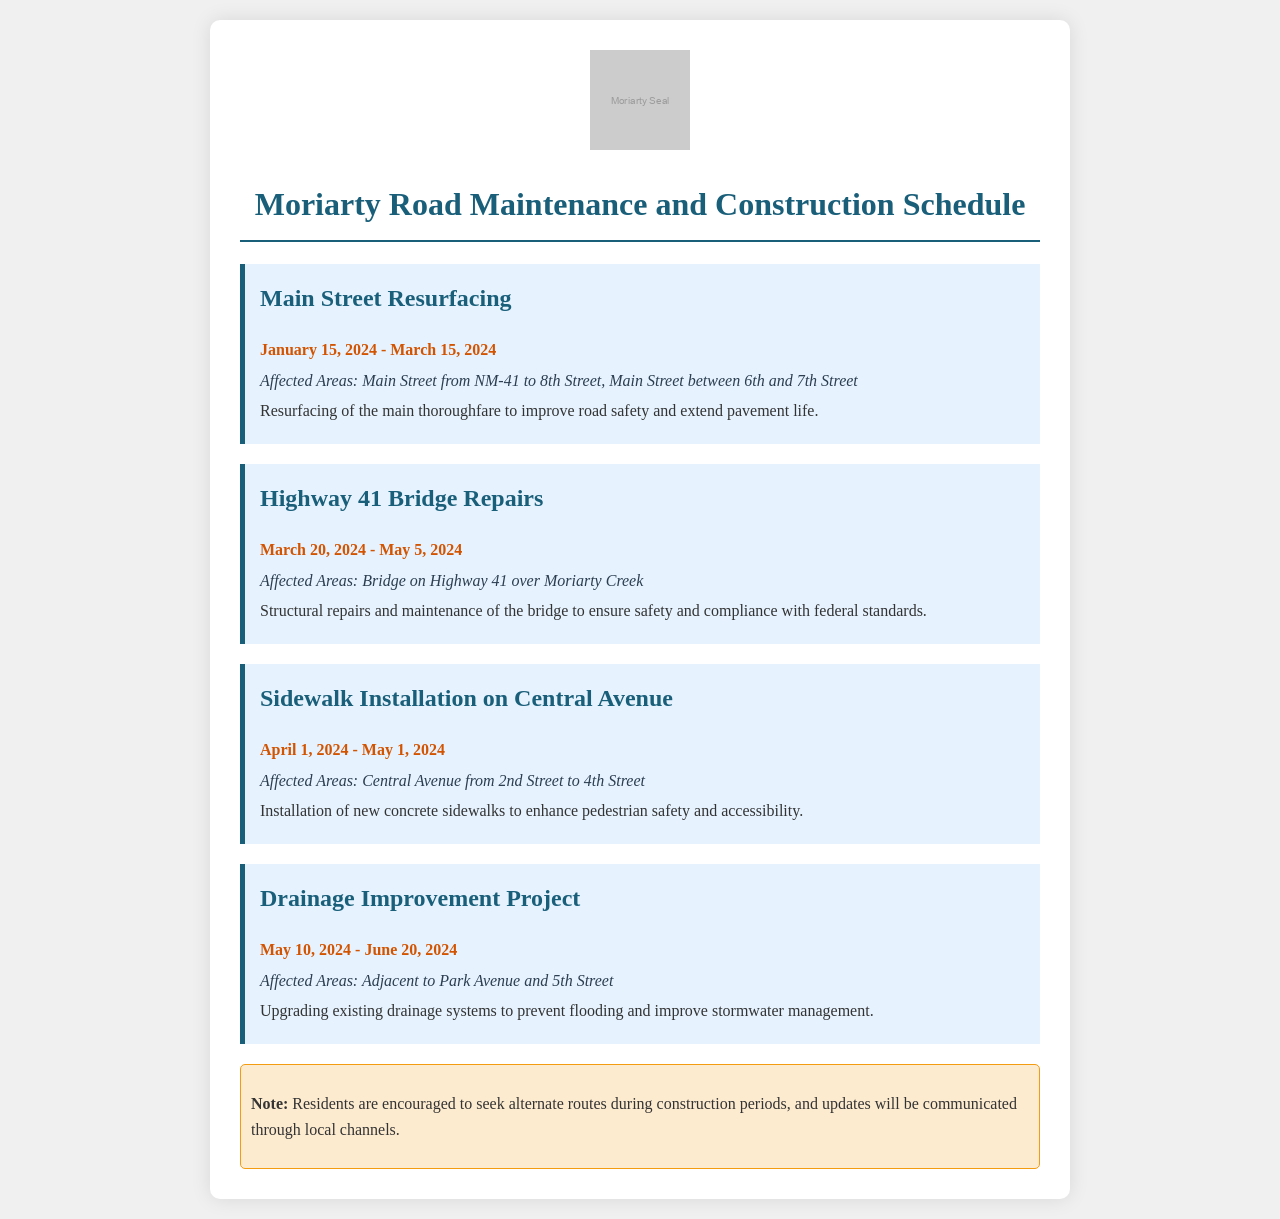what is the start date for the Main Street Resurfacing project? The start date for the Main Street Resurfacing project is specified in the document as January 15, 2024.
Answer: January 15, 2024 what is the end date for the Highway 41 Bridge Repairs? The end date for the Highway 41 Bridge Repairs is detailed as May 5, 2024.
Answer: May 5, 2024 which areas will be affected by the Sidewalk Installation on Central Avenue? The affected areas for the Sidewalk Installation on Central Avenue are listed as Central Avenue from 2nd Street to 4th Street.
Answer: Central Avenue from 2nd Street to 4th Street how long is the drainage improvement project scheduled to last? The duration of the Drainage Improvement Project is calculated from May 10, 2024, to June 20, 2024, which spans 41 days.
Answer: 41 days what is the purpose of the Highway 41 Bridge Repairs? The document states that the purpose of the Highway 41 Bridge Repairs is to ensure safety and compliance with federal standards.
Answer: Safety and compliance which project occurs after the Main Street Resurfacing? By analyzing the schedule, the project that follows the Main Street Resurfacing is the Highway 41 Bridge Repairs.
Answer: Highway 41 Bridge Repairs how many construction projects are listed in the document? The document lists a total of four construction projects related to road maintenance and construction.
Answer: Four what type of maintenance is being performed on Main Street? The maintenance being performed on Main Street is identified in the document as resurfacing.
Answer: Resurfacing how should residents respond during the construction periods? The document advises residents to seek alternate routes during construction periods.
Answer: Seek alternate routes 